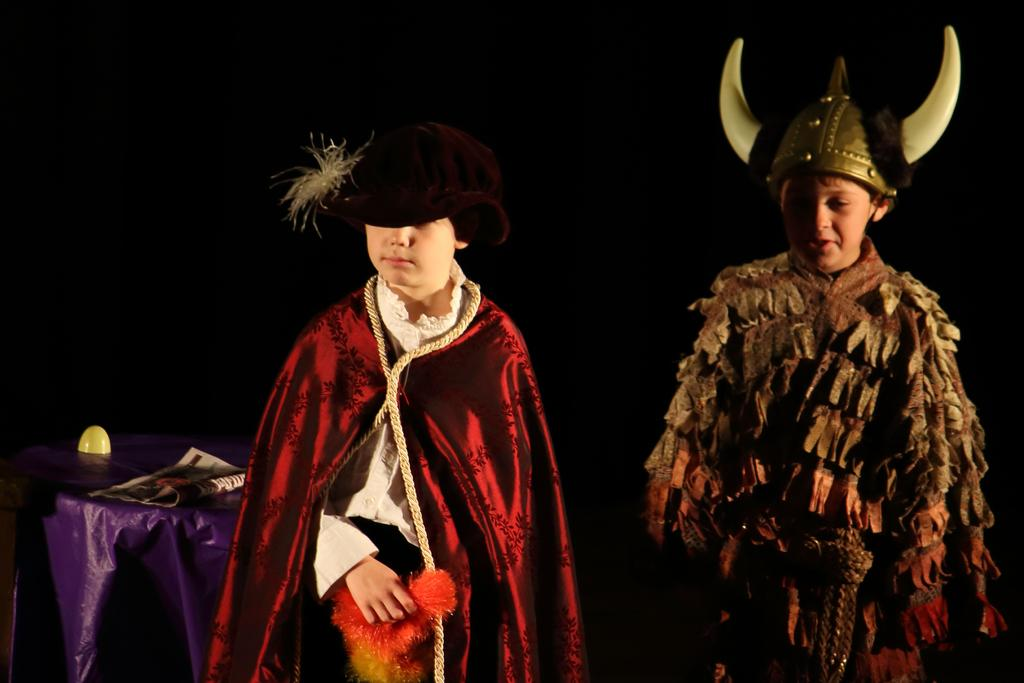How many children are in the image? There are two children in the image. What are the children wearing? The children are wearing costumes. What can be seen on the table in the image? There is a newspaper on the table. What is the color of the background in the image? The background of the image is dark. What is the queen doing in the image? There is no queen present in the image. How many points can be seen on the children's costumes? The provided facts do not mention any points on the children's costumes, so we cannot determine the number of points. What is the sister of the children doing in the image? The provided facts do not mention a sister, so we cannot determine what the sister is doing in the image. 